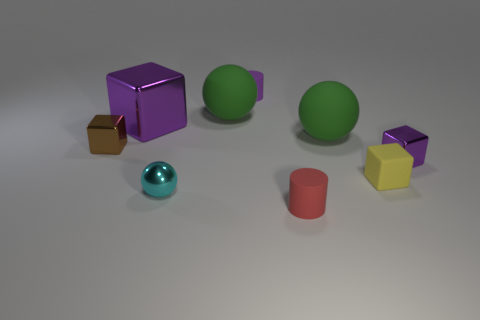Are there any other cyan things that have the same shape as the tiny cyan object?
Keep it short and to the point. No. Does the large block have the same material as the ball that is on the right side of the small red cylinder?
Offer a terse response. No. There is a rubber cylinder that is in front of the rubber sphere that is in front of the big purple cube that is behind the small yellow cube; what is its color?
Provide a short and direct response. Red. There is a brown thing that is the same size as the cyan thing; what is it made of?
Your answer should be very brief. Metal. How many red things are the same material as the cyan sphere?
Give a very brief answer. 0. There is a purple metallic block behind the small brown block; does it have the same size as the cylinder that is in front of the yellow object?
Offer a very short reply. No. What is the color of the sphere that is to the right of the small red thing?
Make the answer very short. Green. What material is the cylinder that is the same color as the big metallic block?
Provide a short and direct response. Rubber. What number of small metal balls have the same color as the big shiny thing?
Offer a very short reply. 0. Does the brown thing have the same size as the green object in front of the large block?
Offer a terse response. No. 